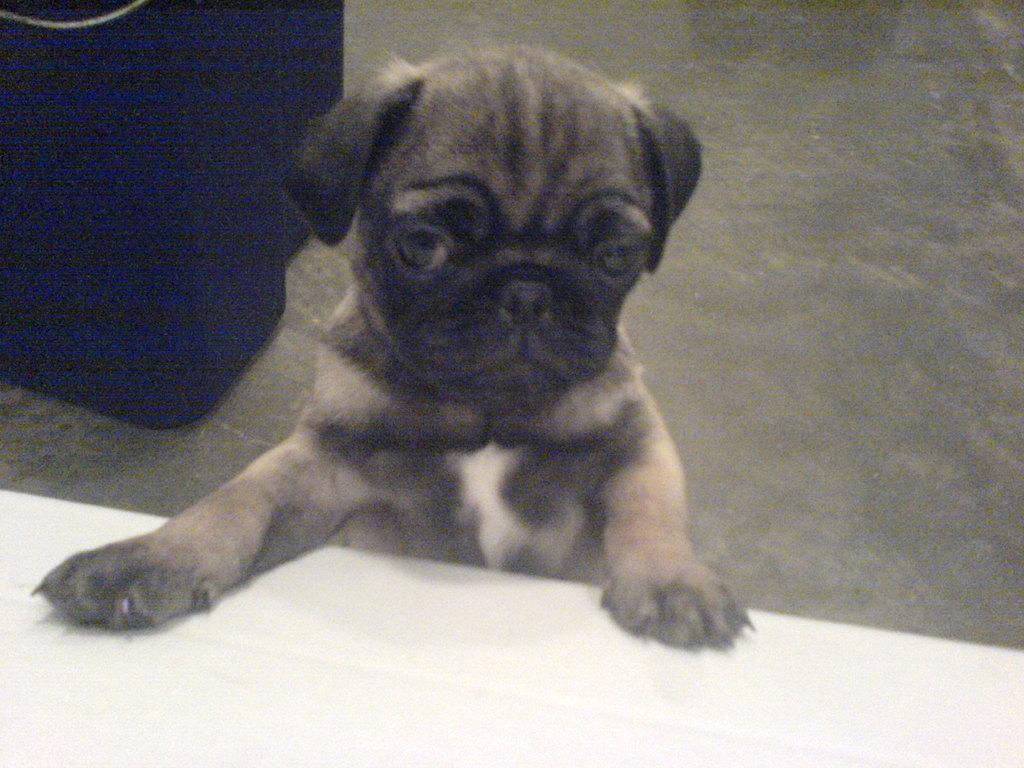How would you summarize this image in a sentence or two? In this picture, we see a dog and it is trying to put its legs on the white table. In the left top, we see an object which looks like a box. It is in blue color. In the background, we see the floor. 